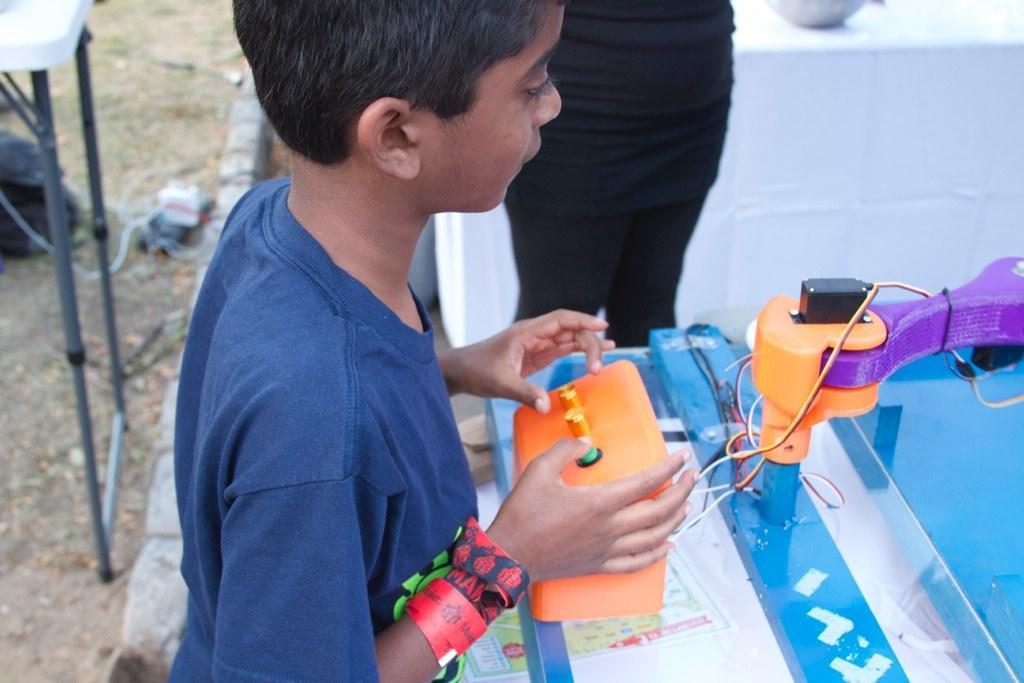How would you summarize this image in a sentence or two? In the image we can see a boy standing, wearing clothes and hand bands. Here we can see cable wire and an electronic device. Here we can see the truncated image of the person and the background is slightly blurred. 